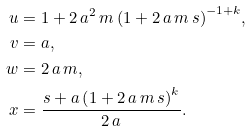<formula> <loc_0><loc_0><loc_500><loc_500>u & = 1 + 2 \, a ^ { 2 } \, m \, { \left ( 1 + 2 \, a \, m \, s \right ) } ^ { - 1 + k } , \\ v & = a , \\ w & = 2 \, a \, m , \\ x & = \frac { s + a \, { \left ( 1 + 2 \, a \, m \, s \right ) } ^ { k } } { 2 \, a } .</formula> 